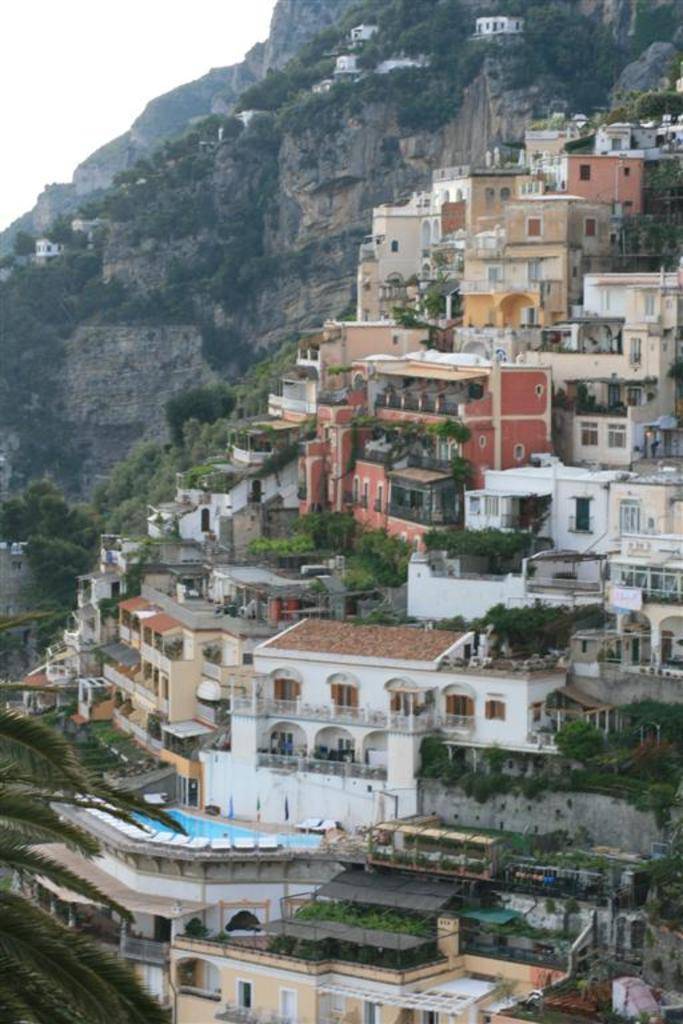What type of structures can be seen in the image? There are buildings in the image. What else is present in the image besides the buildings? There are plants in the image. Where are the buildings and plants located? The buildings and plants are on a hill. What part of the natural environment is visible in the image? The sky is visible in the top left of the image. Can you tell me how many strangers are holding a pocket in the image? There are no strangers or pockets present in the image. What type of fiction is being read by the plants in the image? There are no plants reading fiction in the image; the plants are not sentient beings. 